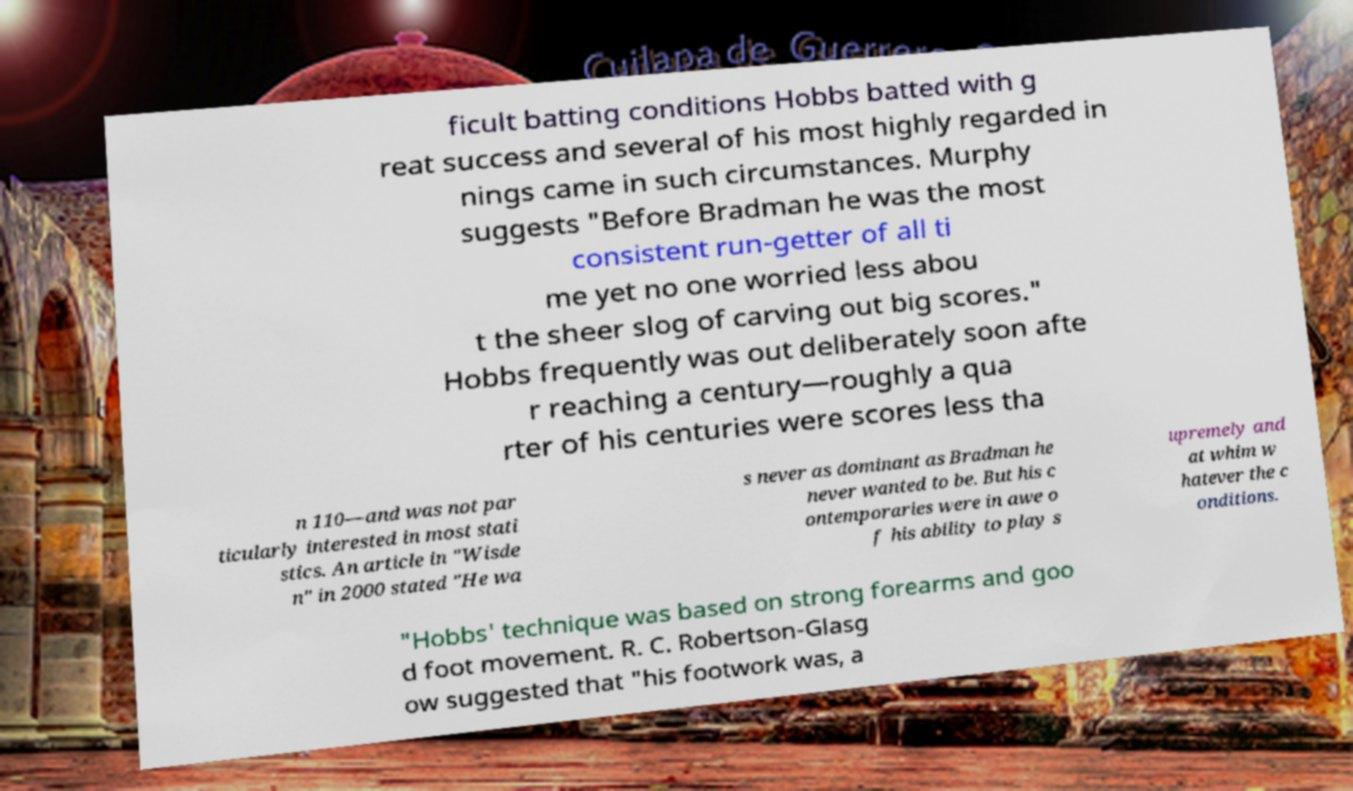What messages or text are displayed in this image? I need them in a readable, typed format. ficult batting conditions Hobbs batted with g reat success and several of his most highly regarded in nings came in such circumstances. Murphy suggests "Before Bradman he was the most consistent run-getter of all ti me yet no one worried less abou t the sheer slog of carving out big scores." Hobbs frequently was out deliberately soon afte r reaching a century—roughly a qua rter of his centuries were scores less tha n 110—and was not par ticularly interested in most stati stics. An article in "Wisde n" in 2000 stated "He wa s never as dominant as Bradman he never wanted to be. But his c ontemporaries were in awe o f his ability to play s upremely and at whim w hatever the c onditions. "Hobbs' technique was based on strong forearms and goo d foot movement. R. C. Robertson-Glasg ow suggested that "his footwork was, a 